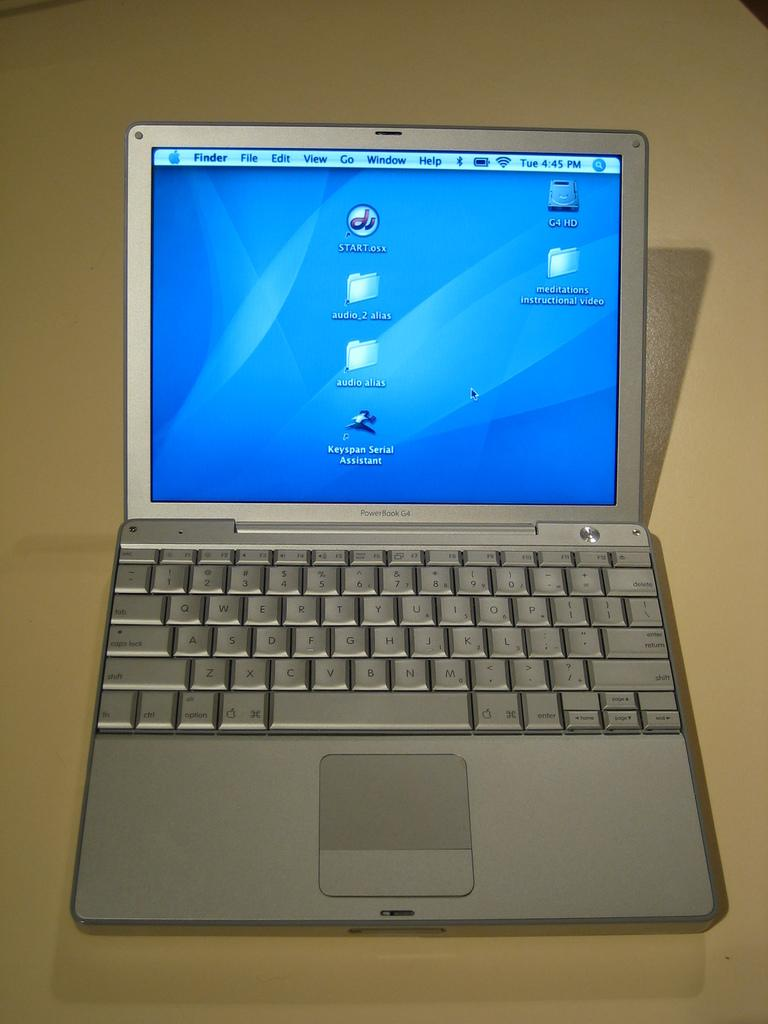<image>
Relay a brief, clear account of the picture shown. Black lettering on a small laptop identifies it as a PowerBook G4. 